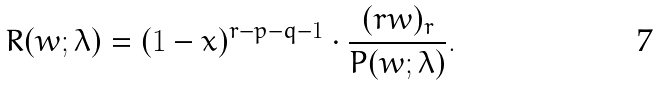Convert formula to latex. <formula><loc_0><loc_0><loc_500><loc_500>R ( w ; \lambda ) = ( 1 - x ) ^ { r - p - q - 1 } \cdot \frac { ( r w ) _ { r } } { P ( w ; \lambda ) } .</formula> 